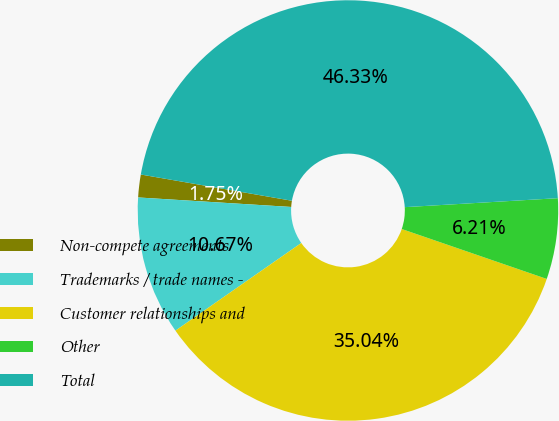Convert chart to OTSL. <chart><loc_0><loc_0><loc_500><loc_500><pie_chart><fcel>Non-compete agreements<fcel>Trademarks / trade names -<fcel>Customer relationships and<fcel>Other<fcel>Total<nl><fcel>1.75%<fcel>10.67%<fcel>35.04%<fcel>6.21%<fcel>46.33%<nl></chart> 